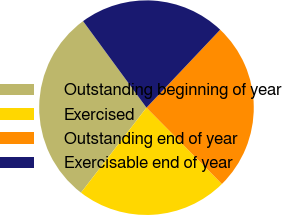<chart> <loc_0><loc_0><loc_500><loc_500><pie_chart><fcel>Outstanding beginning of year<fcel>Exercised<fcel>Outstanding end of year<fcel>Exercisable end of year<nl><fcel>29.49%<fcel>22.85%<fcel>25.54%<fcel>22.12%<nl></chart> 